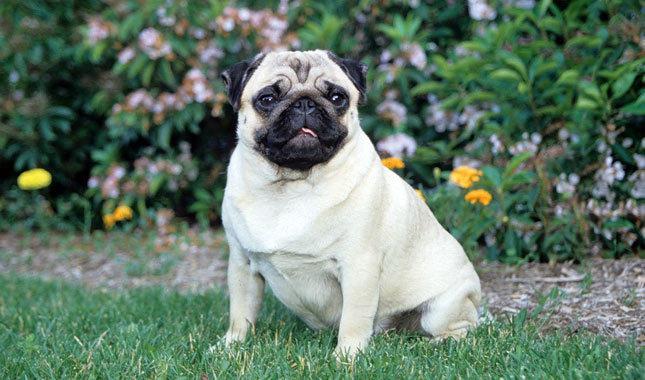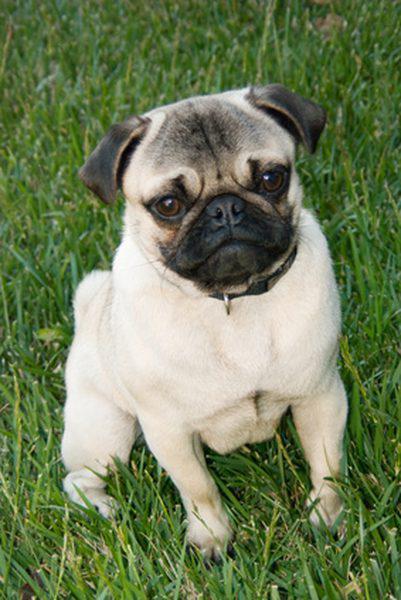The first image is the image on the left, the second image is the image on the right. Evaluate the accuracy of this statement regarding the images: "At least one dog has a visible collar.". Is it true? Answer yes or no. Yes. 